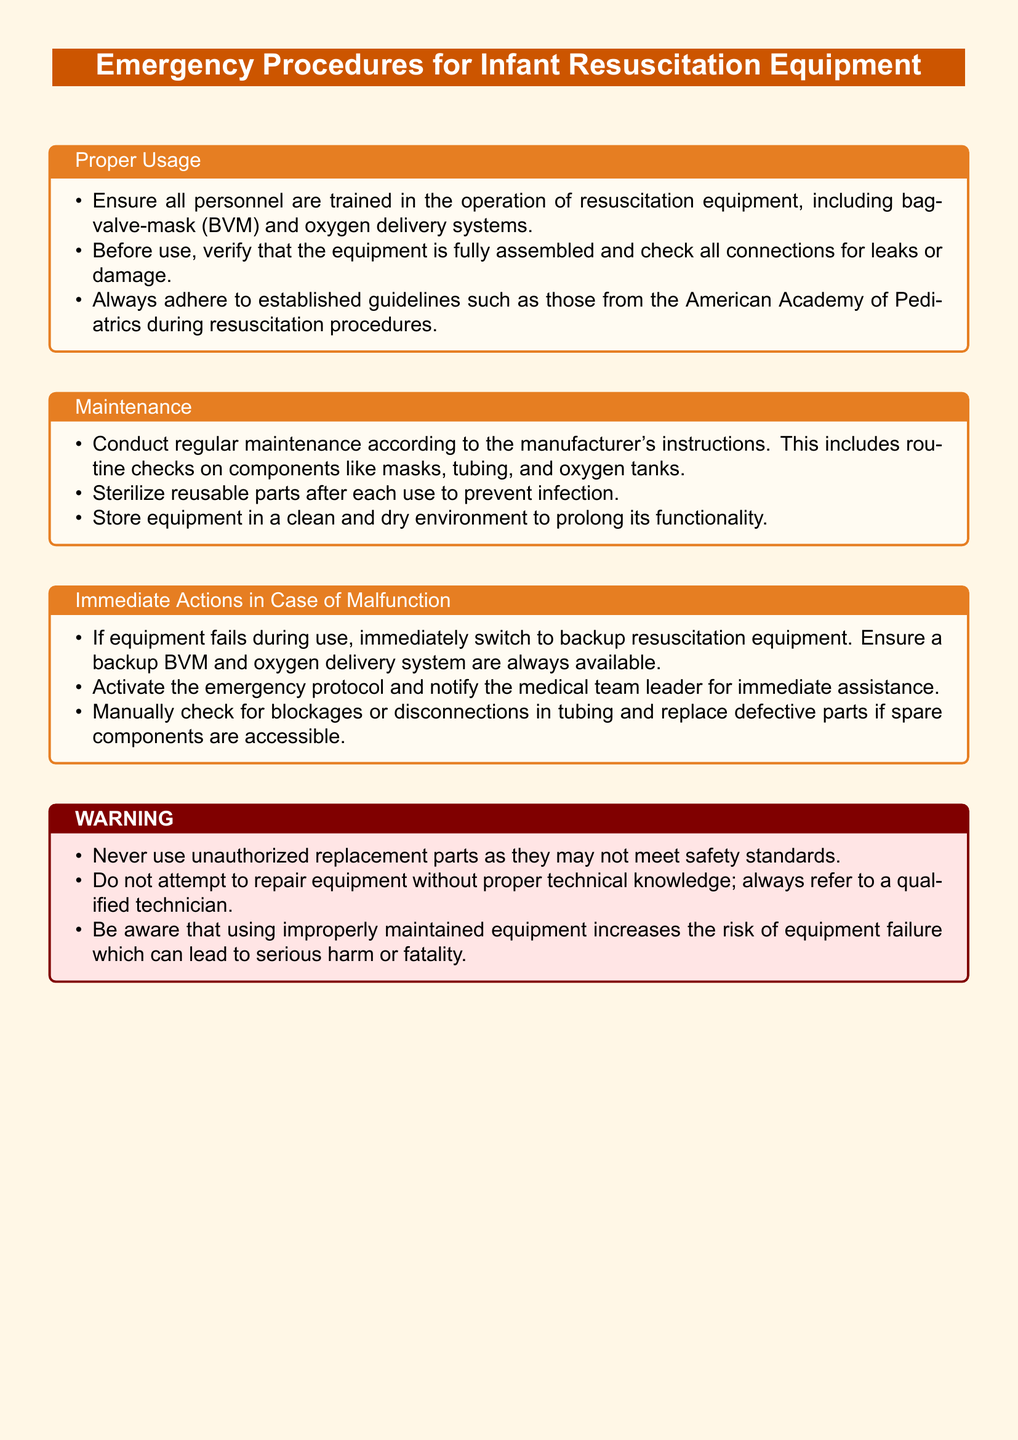What is the title of the document? The title is prominently displayed at the top of the document, which is "Emergency Procedures for Infant Resuscitation Equipment."
Answer: Emergency Procedures for Infant Resuscitation Equipment What color is the warning label? The warning label is described using the color specification in the document, which is red and light red.
Answer: Red What should be done before using resuscitation equipment? The document states that all personnel should be trained and the equipment should be verified for assembly and connections.
Answer: Verify assembly and connections What must never be used according to the warning? The warning specifically states that unauthorized replacement parts should never be used.
Answer: Unauthorized replacement parts What is the first action to take if the equipment fails? The document outlines that the first action should be to switch to backup resuscitation equipment.
Answer: Switch to backup equipment According to the maintenance section, what should be sterilized? The maintenance guidelines indicate that reusable parts need to be sterilized after each use.
Answer: Reusable parts How often should maintenance be conducted? The document specifies that regular maintenance should be conducted according to the manufacturer's instructions.
Answer: Regularly What should be notified if there is a malfunction? The warning section emphasizes the importance of notifying the medical team leader during an equipment failure.
Answer: Medical team leader What color are section titles in the document? The section titles are specified to be in a color that is a shade of orange.
Answer: Section color (orange) 